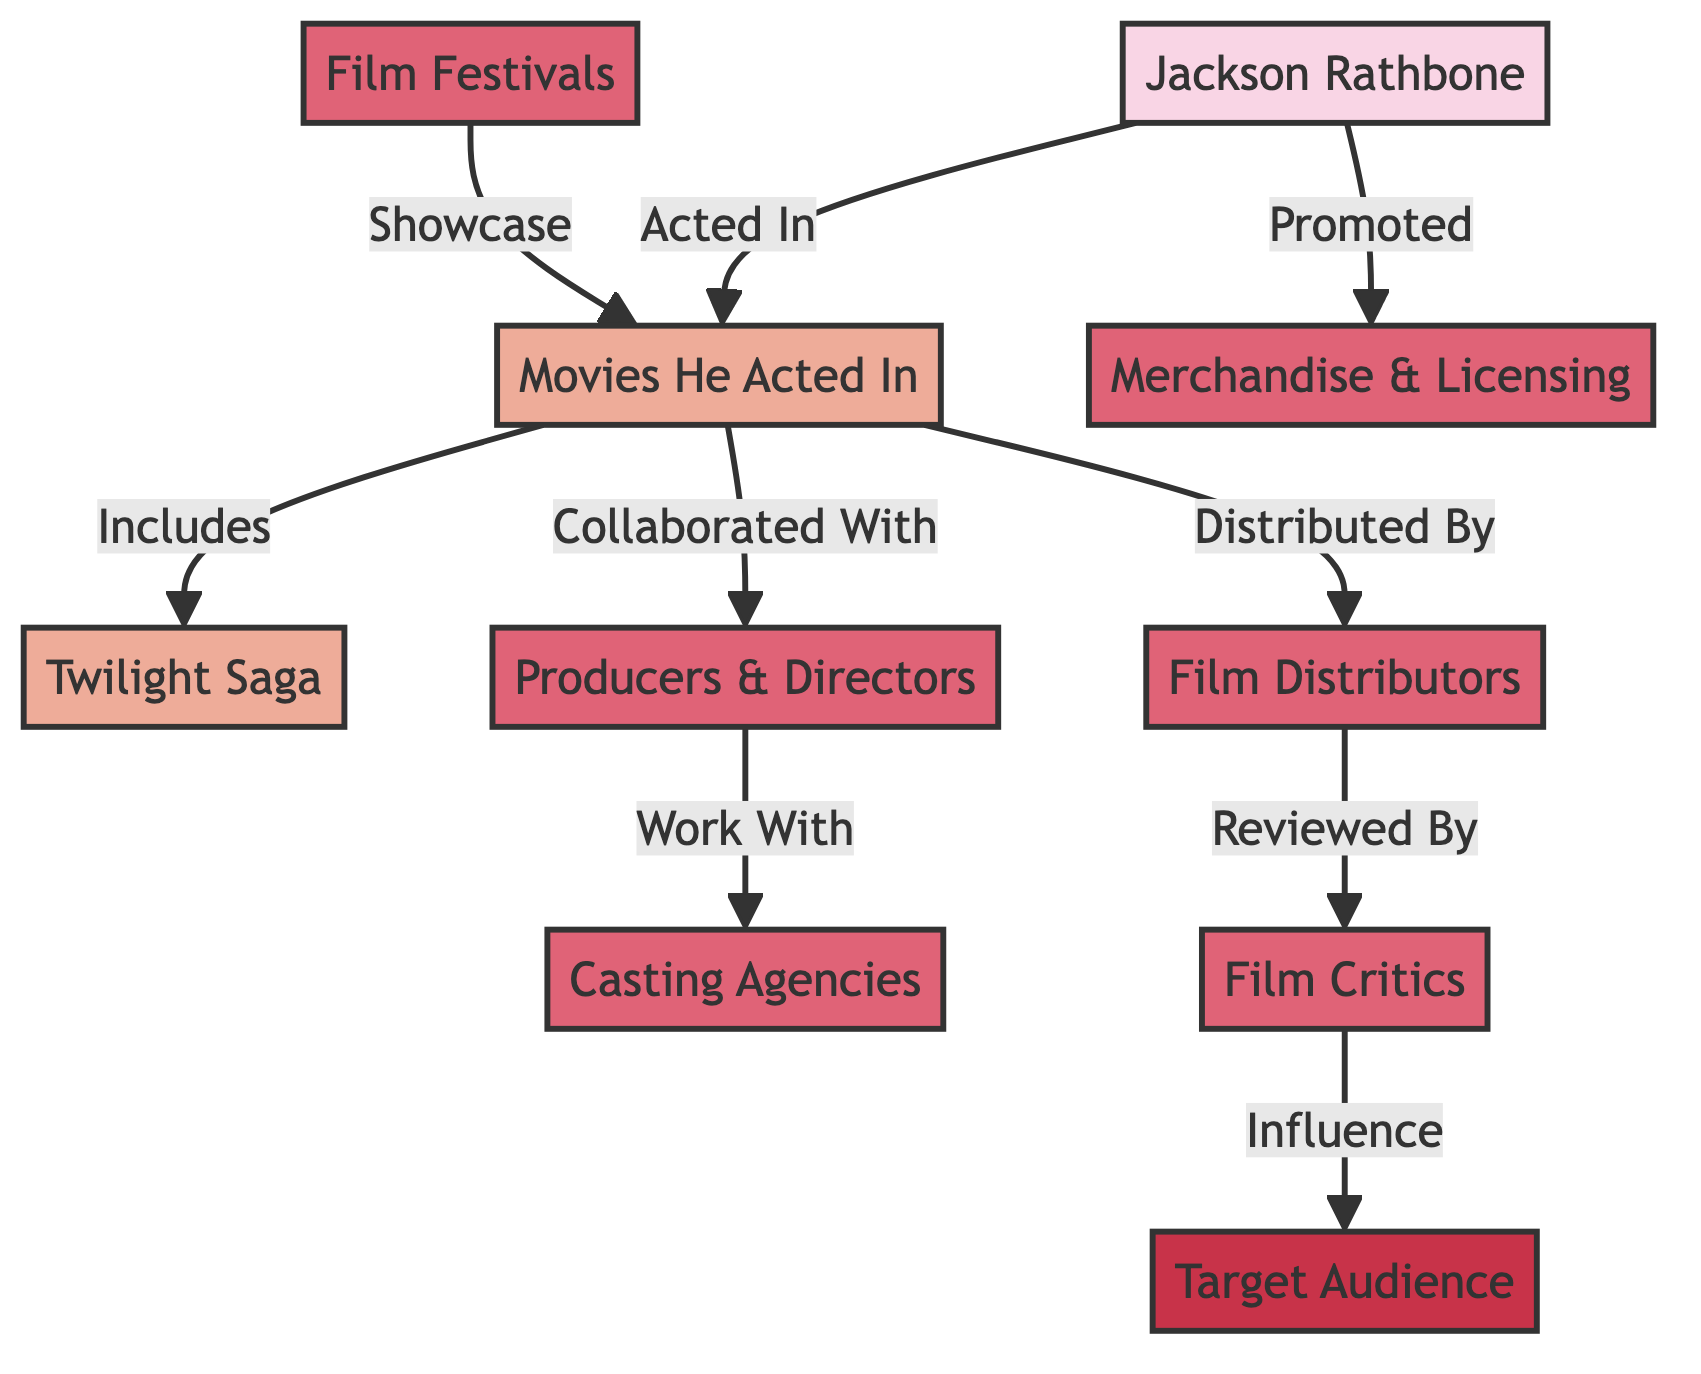What is the primary role of Jackson Rathbone in the diagram? Jackson Rathbone is depicted as an actor, which establishes his role in the movie industry supply chain.
Answer: actor Which specific movie is highlighted in the diagram that Jackson Rathbone acted in? The direct connection from the Movies He Acted In node points to the Twilight Saga, establishing that it is a specific movie associated with Jackson Rathbone.
Answer: Twilight Saga How many different types of industry nodes are present in the diagram? By counting the unique industry nodes listed, including Producers & Directors, Casting Agencies, Film Distributors, Film Critics, Film Festivals, and Merchandise & Licensing, we find that there are six distinct industry nodes.
Answer: 6 What does the node "Film Critics" influence according to the diagram? The directed arrow from Film Critics node to Target Audience indicates that Film Critics have an influence over the Target Audience, shaping their perceptions of the films.
Answer: Target Audience Which entity promotes the Merchandise & Licensing related to Jackson Rathbone's movies? The path shows that Jackson Rathbone directly promotes the Merchandise & Licensing, linking him to this aspect of the supply chain without any intermediaries.
Answer: Jackson Rathbone How many connections does the "Movies He Acted In" node have? The Movies He Acted In node connects to several nodes: Twilight Saga, Producers & Directors, Film Distributors, and Merchandise & Licensing, making for a total of four connections.
Answer: 4 What would happen if a film is showcased at Film Festivals according to the diagram? The arrow from Film Festivals to Movies He Acted In suggests that films showcased at these festivals will include those that Jackson Rathbone acted in, highlighting his exposure and potential impact.
Answer: Movies He Acted In Who works with the Producers & Directors as indicated in the diagram? The next industry node that connects to Producers & Directors is Casting Agencies, showing that they collaborate with one another in the context of film production.
Answer: Casting Agencies What is indicated by the directed edge from Film Distributors to Film Critics? This edge illustrates that the films distributed by Film Distributors are later reviewed by Film Critics, establishing a flow of evaluation and critique within the industry.
Answer: Film Critics 